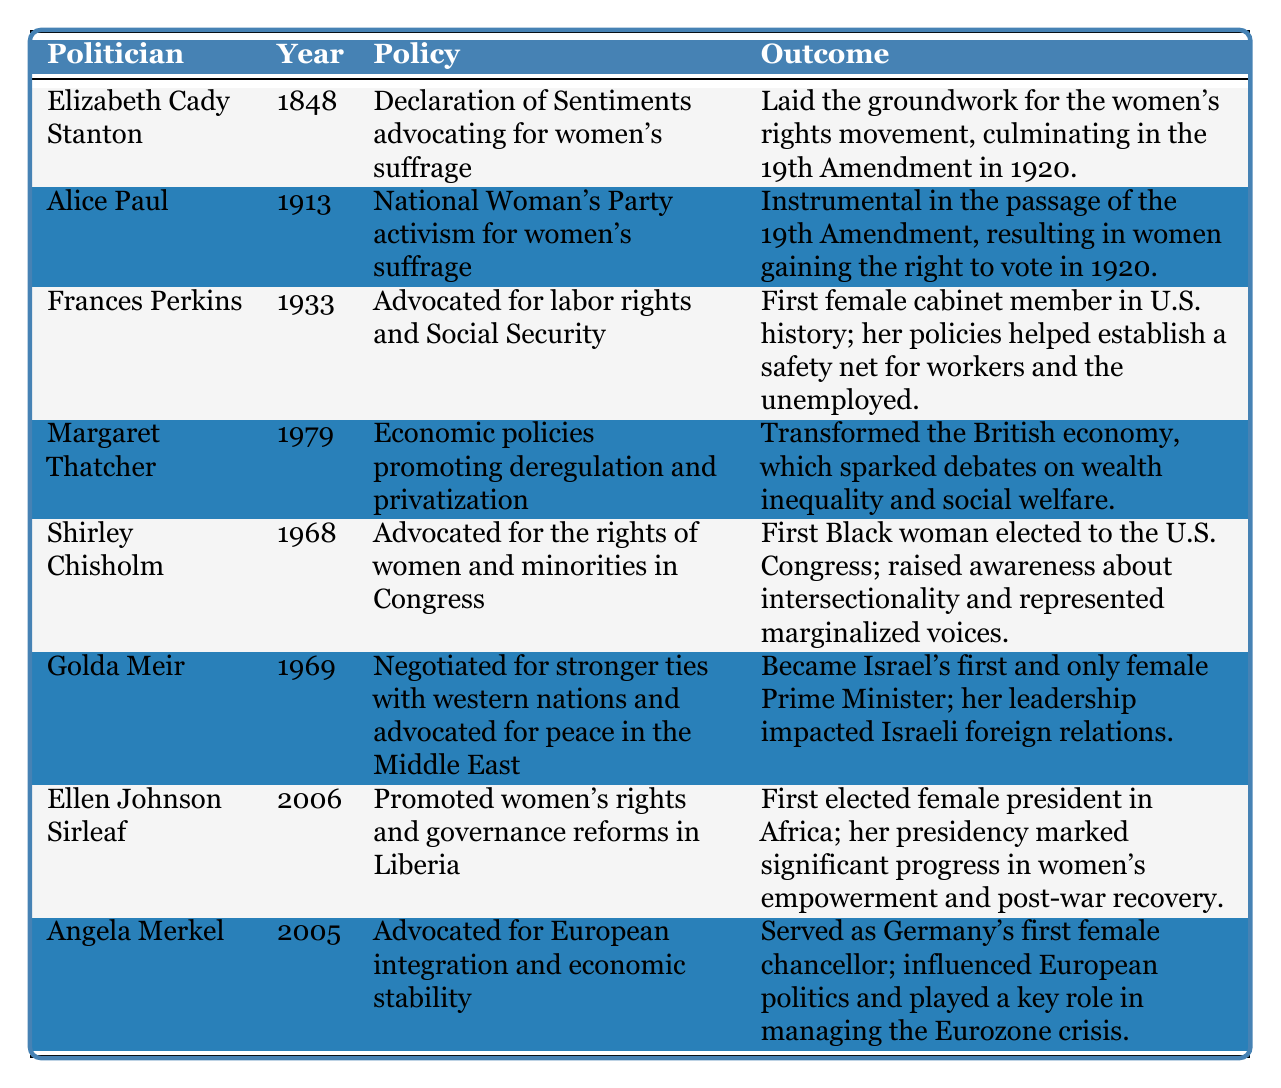What year did Elizabeth Cady Stanton advocate for women's suffrage? The table lists Elizabeth Cady Stanton under the year 1848 for her policy advocating for women's suffrage.
Answer: 1848 Which politician was the first female cabinet member in U.S. history? The table states that Frances Perkins, in 1933, was the first female cabinet member in U.S. history due to her advocacy for labor rights and Social Security.
Answer: Frances Perkins What was the outcome of Alice Paul’s advocacy in 1913? According to the table, Alice Paul's efforts were instrumental in the passage of the 19th Amendment, granting women the right to vote in 1920.
Answer: Women gained the right to vote in 1920 Who were the female politicians advocating for women's rights in the 20th century? The table indicates that Frances Perkins, Shirley Chisholm, and Ellen Johnson Sirleaf, among others, advocated for women's rights during the 20th century.
Answer: Frances Perkins, Shirley Chisholm, Ellen Johnson Sirleaf What policy did Angela Merkel advocate for in 2005? The table shows that Angela Merkel advocated for European integration and economic stability in 2005.
Answer: European integration and economic stability Which politician's outcomes relate to the impact on wealth inequality discussions? According to the table, Margaret Thatcher's economic policies in 1979 transformed the British economy and sparked debates on wealth inequality and social welfare.
Answer: Margaret Thatcher How many years passed between the advocacy of women's suffrage by Elizabeth Cady Stanton and the passing of the 19th Amendment? Elizabeth Cady Stanton advocated in 1848, and the 19th Amendment was passed in 1920, which is a span of 72 years (1920 - 1848 = 72).
Answer: 72 years Did Ellen Johnson Sirleaf serve as Liberia's first female president? Yes, the table confirms that Ellen Johnson Sirleaf was the first elected female president in Africa in 2006.
Answer: Yes Identify the politicians associated with peace advocacy in the table. The table indicates that Golda Meir, through her negotiations for stronger ties and peace in the Middle East in 1969, is associated with peace advocacy.
Answer: Golda Meir Which policy had a direct connection to establishing a safety net for workers in the United States? Frances Perkins’ advocacy for labor rights and Social Security in 1933 established a safety net for workers, as noted in the table.
Answer: Labor rights and Social Security What was the primary focus of Shirley Chisholm's advocacy in Congress? The table highlights that Shirley Chisholm advocated for the rights of women and minorities, particularly as the first Black woman elected to the U.S. Congress.
Answer: Rights of women and minorities Who was responsible for negotiating stronger ties with western nations in the 1960s? Golda Meir is credited with negotiating for stronger ties with western nations in 1969, as stated in the table.
Answer: Golda Meir 